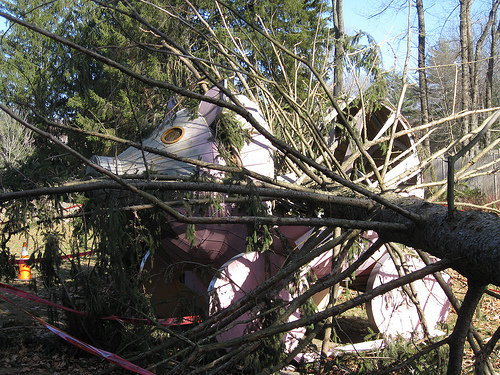<image>
Is there a wheel behind the stick? Yes. From this viewpoint, the wheel is positioned behind the stick, with the stick partially or fully occluding the wheel. 